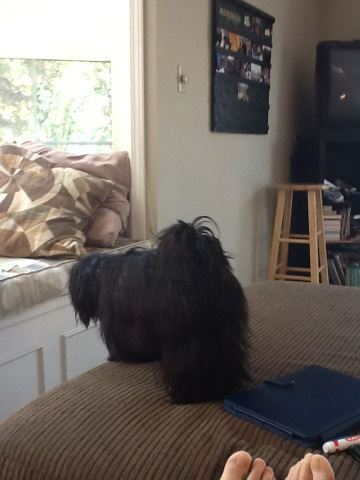what color is this dog? The dog in the image is black. It appears to have a sleek and shiny coat, which is fully black, contributing to its overall adorable appearance. 